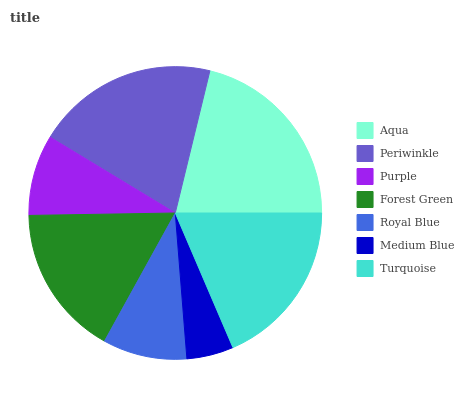Is Medium Blue the minimum?
Answer yes or no. Yes. Is Aqua the maximum?
Answer yes or no. Yes. Is Periwinkle the minimum?
Answer yes or no. No. Is Periwinkle the maximum?
Answer yes or no. No. Is Aqua greater than Periwinkle?
Answer yes or no. Yes. Is Periwinkle less than Aqua?
Answer yes or no. Yes. Is Periwinkle greater than Aqua?
Answer yes or no. No. Is Aqua less than Periwinkle?
Answer yes or no. No. Is Forest Green the high median?
Answer yes or no. Yes. Is Forest Green the low median?
Answer yes or no. Yes. Is Aqua the high median?
Answer yes or no. No. Is Periwinkle the low median?
Answer yes or no. No. 